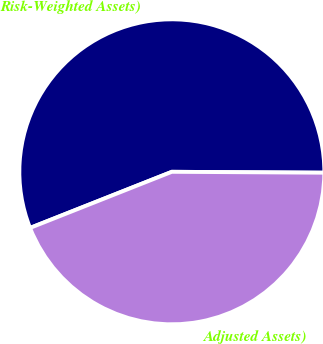Convert chart. <chart><loc_0><loc_0><loc_500><loc_500><pie_chart><fcel>Risk-Weighted Assets)<fcel>Adjusted Assets)<nl><fcel>56.09%<fcel>43.91%<nl></chart> 